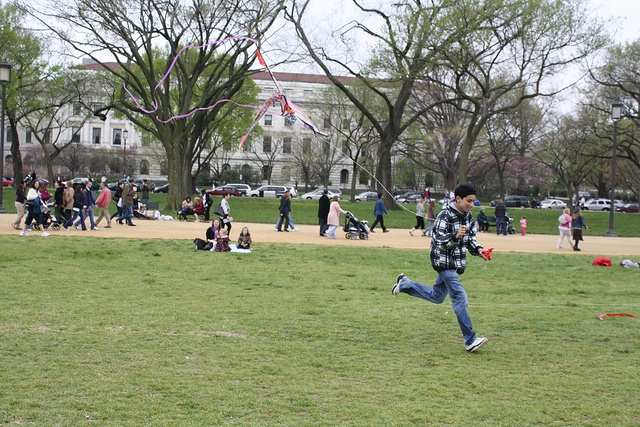Describe the objects in this image and their specific colors. I can see people in lightgray, black, gray, darkgreen, and darkgray tones, people in lightgray, black, gray, and navy tones, kite in lightgray, lavender, darkgray, gray, and lightpink tones, people in lightgray, gray, black, and navy tones, and car in lightgray, gray, darkgray, lavender, and black tones in this image. 